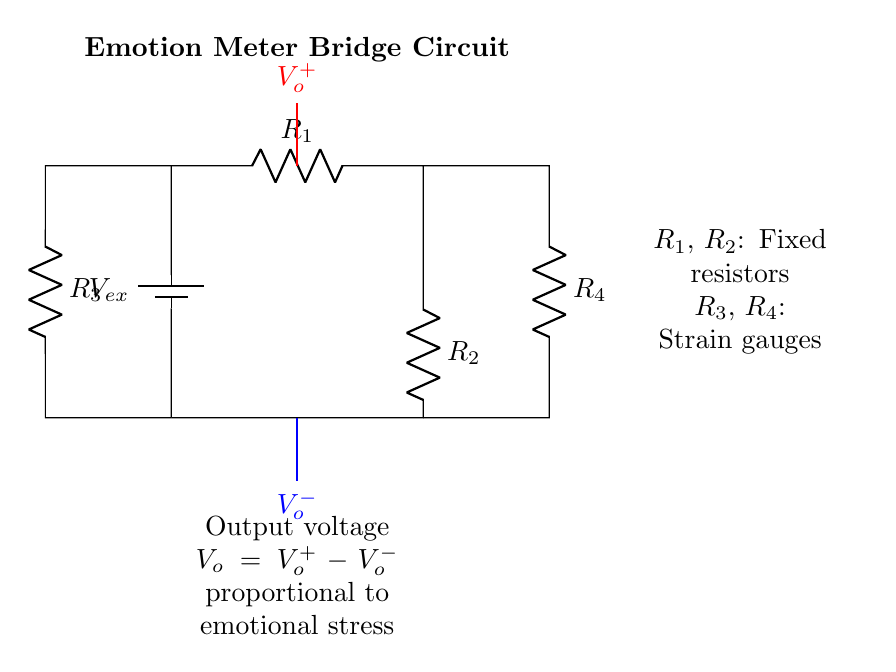What is the type of circuit shown? The circuit is a bridge configuration, specifically designed to measure variations in resistance using strain gauges. This configuration allows for precise measurements due to its ability to cancel out effects from the resistors.
Answer: Bridge circuit What do the elements R3 and R4 represent? R3 and R4 are strain gauges, which change their resistance in response to mechanical strain or stress. This change is then measured for understanding physical stress responses.
Answer: Strain gauges What is the purpose of the output voltage V_o? The output voltage V_o is used to indicate the difference in potential between the two points, serving as a measure of emotional stress based on the resistance changes of the strain gauges.
Answer: Measure emotional stress How many resistors are in the circuit? There are four resistors total: R1, R2, R3, and R4. They include two fixed resistors and two strain gauges.
Answer: Four resistors What is the significance of the battery in the circuit? The battery provides the necessary voltage (V_ex) to the circuit, allowing current to flow and enabling the measurement of voltage differences across the strain gauges.
Answer: Power supply What happens if one strain gauge experiences more stress than the other? If one strain gauge experiences more stress, it will have a higher resistance than the other, leading to a proportional change in output voltage V_o, indicating a higher emotional stress reading.
Answer: Output voltage changes What is the relationship between V_o and emotional stress? V_o is directly proportional to emotional stress; as stress increases, the change in resistance from the strain gauges affects V_o, allowing it to reflect the level of stress experienced.
Answer: Directly proportional 